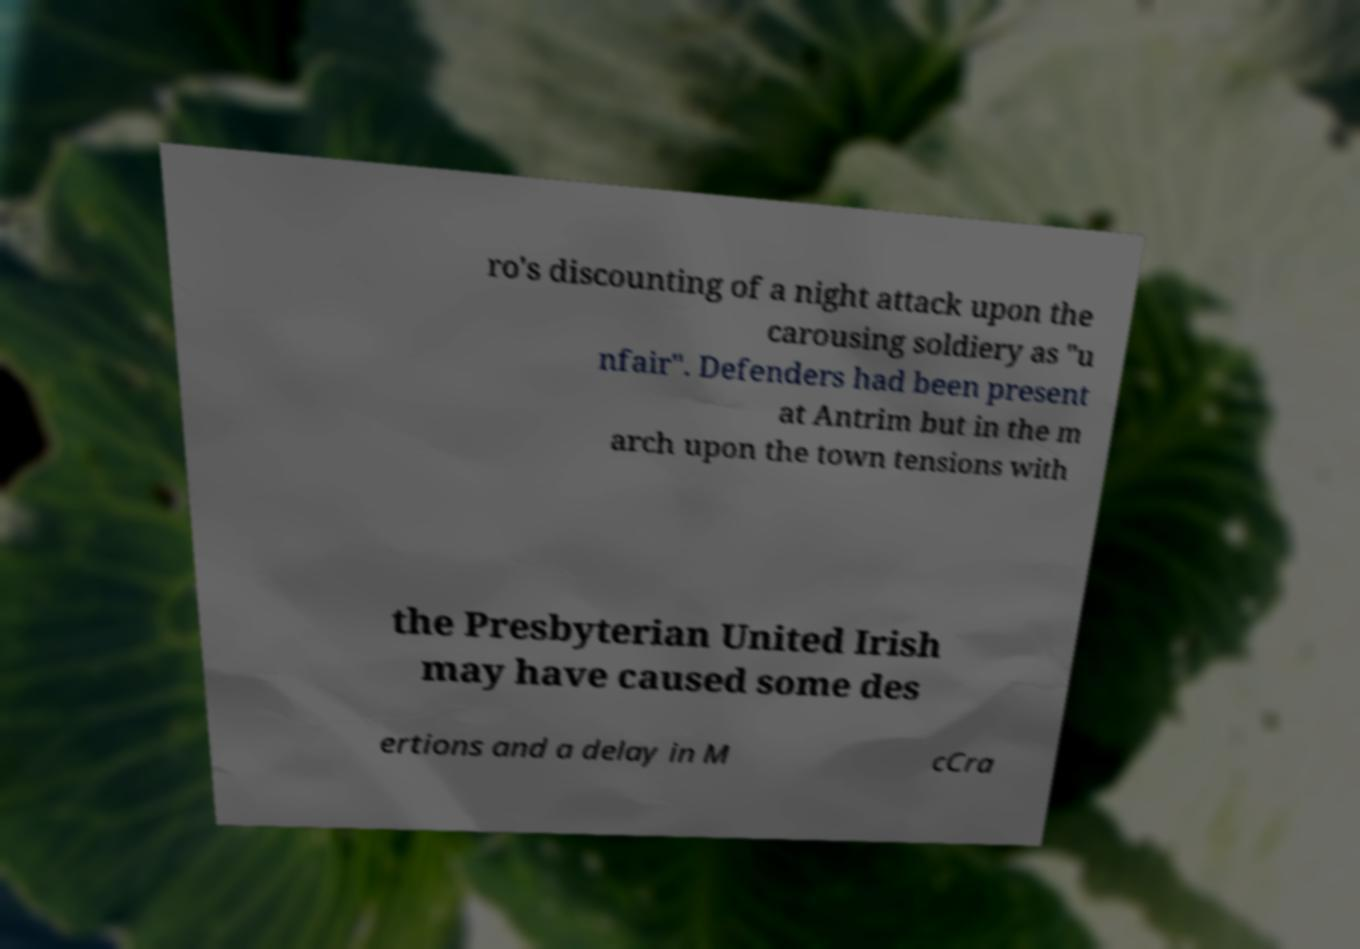What messages or text are displayed in this image? I need them in a readable, typed format. ro's discounting of a night attack upon the carousing soldiery as "u nfair". Defenders had been present at Antrim but in the m arch upon the town tensions with the Presbyterian United Irish may have caused some des ertions and a delay in M cCra 